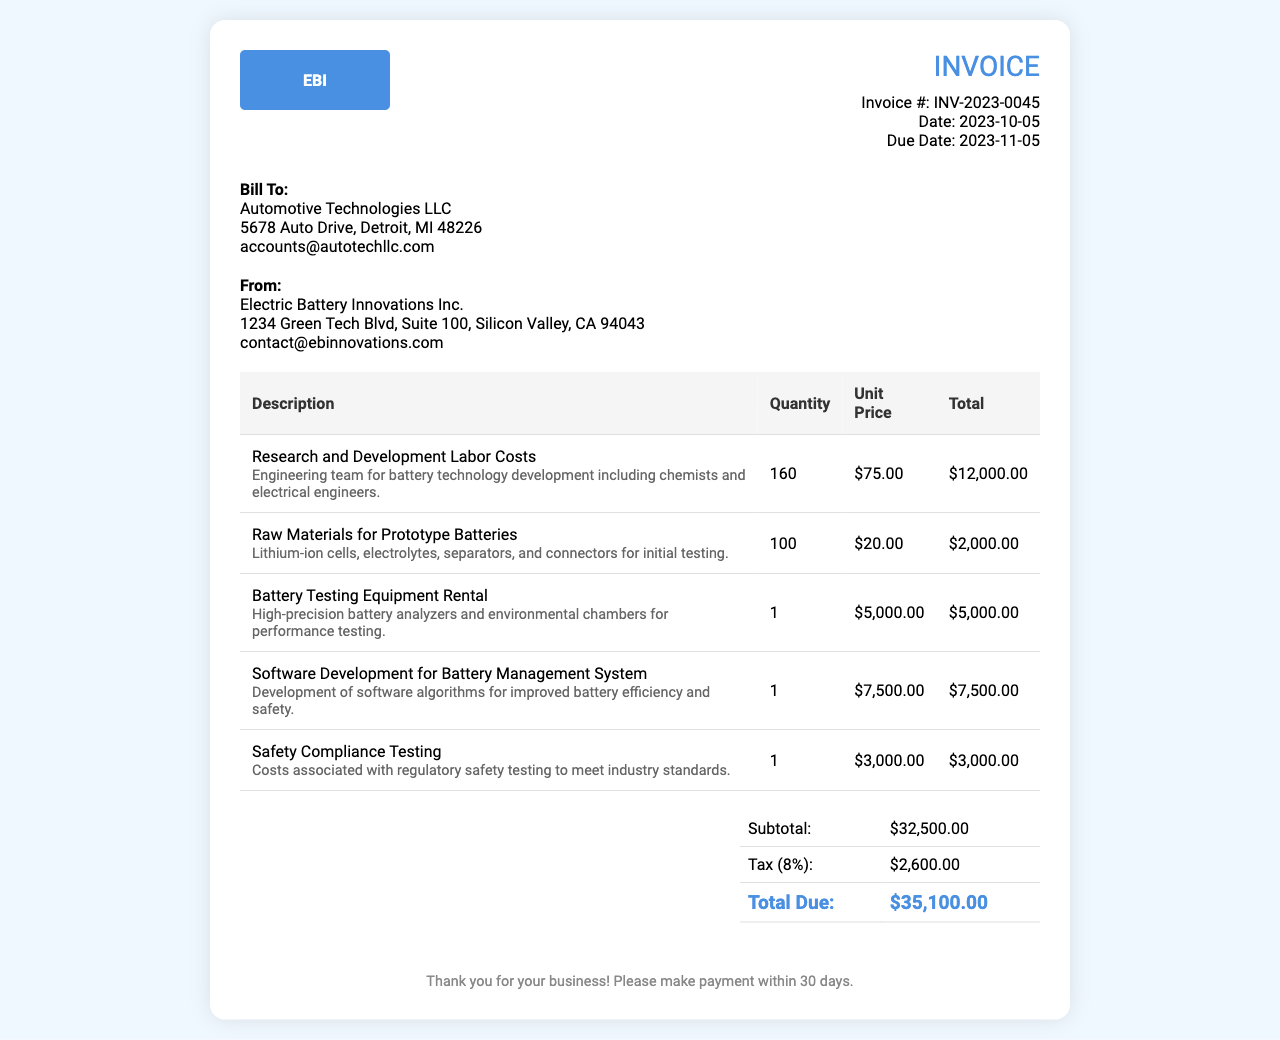What is the invoice number? The invoice number is specified in the document as a unique identifier for this invoice.
Answer: INV-2023-0045 What is the due date? The due date indicates when the payment should be made. It is clearly stated in the document.
Answer: 2023-11-05 What is the quantity of Research and Development Labor Costs? The quantity indicates the number of hours worked, which is detailed in the invoice.
Answer: 160 What is the unit price for Raw Materials for Prototype Batteries? The unit price is listed for each item, showing the cost per unit for raw materials.
Answer: $20.00 What is the total due amount? The total due amount is the final figure that sums up all costs including taxes.
Answer: $35,100.00 What is the tax percentage applied? The tax percentage is stated in the summary, reflecting the applicable sales tax on the subtotal.
Answer: 8% Which company is billing Automotive Technologies LLC? The document specifies the company that is issuing the invoice.
Answer: Electric Battery Innovations Inc What item has the highest unit price? The item with the highest unit price indicates the cost of the most expensive service or product in the invoice.
Answer: Battery Testing Equipment Rental What costs are associated with regulatory compliance? This cost represents a specific regulatory requirement included in the itemized charges.
Answer: Safety Compliance Testing 